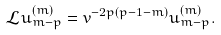<formula> <loc_0><loc_0><loc_500><loc_500>\mathcal { L } u ^ { ( m ) } _ { m - p } = v ^ { - 2 p ( p - 1 - m ) } u ^ { ( m ) } _ { m - p } .</formula> 